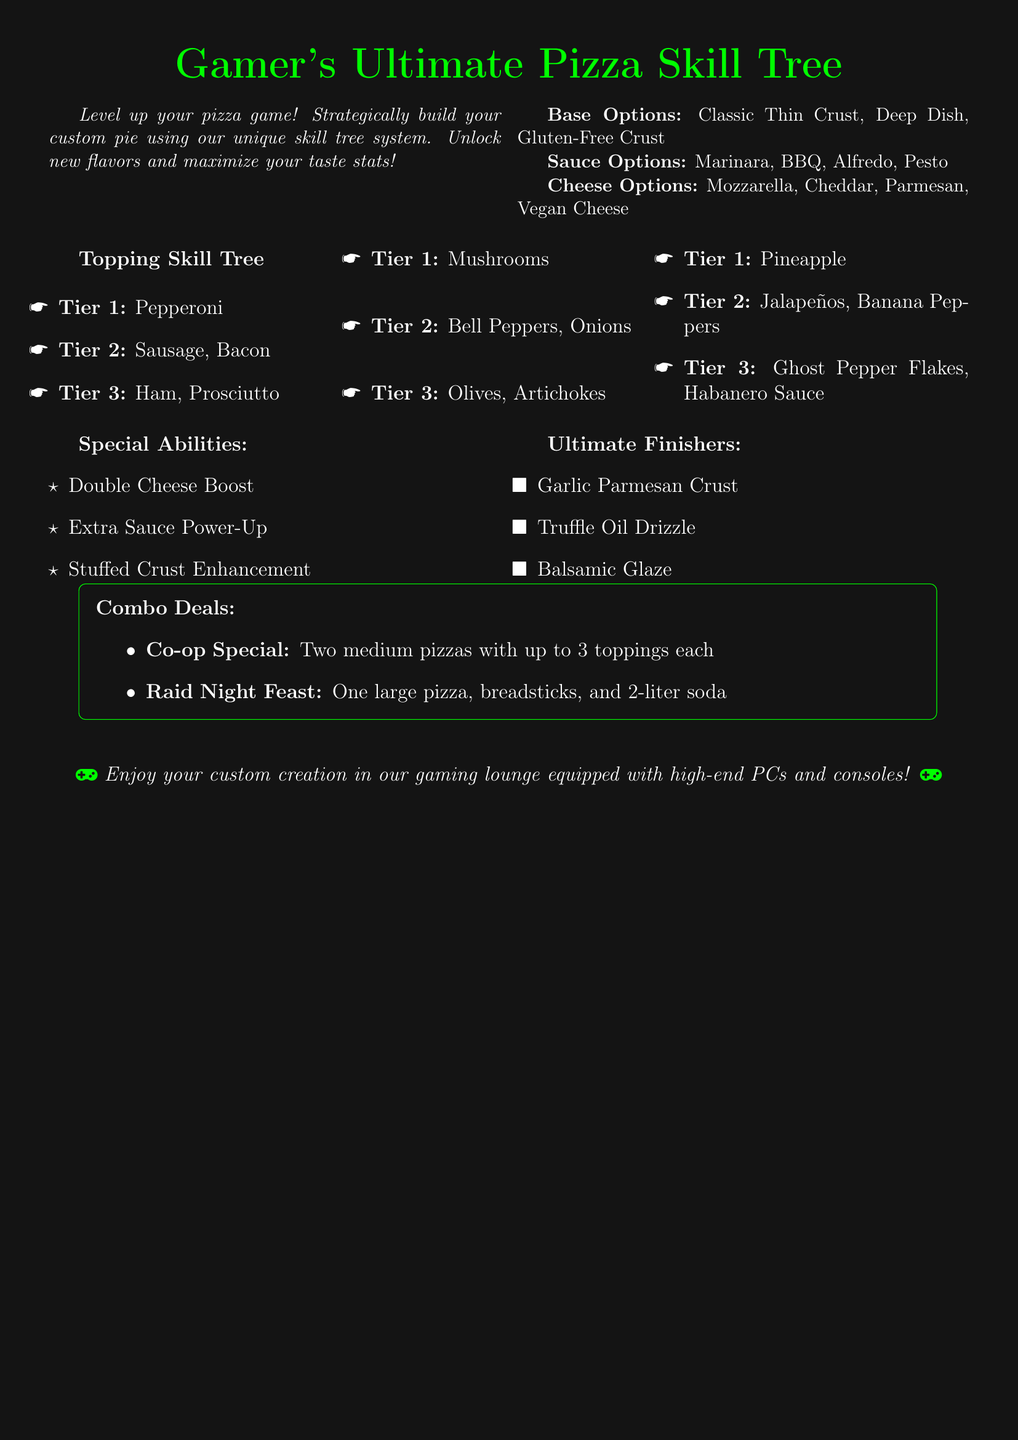What are the base options? The base options are listed directly under the "Base Options" section in the document, which include Classic Thin Crust, Deep Dish, and Gluten-Free Crust.
Answer: Classic Thin Crust, Deep Dish, Gluten-Free Crust What is the highest tier of toppings? The highest tier of toppings is found in the "Topping Skill Tree" section, mentioning the toppings at Tier 3.
Answer: Ghost Pepper Flakes, Habanero Sauce, Olives, Artichokes, Ham, Prosciutto, Jalapeños, Banana Peppers, Sausage, Bacon How many special abilities are listed? The special abilities are outlined in the "Special Abilities" section, and counting them gives the total number.
Answer: 3 What is the co-op special deal? The co-op special is described under "Combo Deals," detailing its contents and format.
Answer: Two medium pizzas with up to 3 toppings each Which pizza base option does not contain gluten? This question refers to the gluten-free option mentioned among the base choices.
Answer: Gluten-Free Crust How many tiers of toppings are available? The tiers of toppings are outlined in the "Topping Skill Tree" with each tier clearly defined.
Answer: 3 What is an ultimate finisher? Ultimate finishers are described in their designated section, detailing a specific type of enhancement for the pizza.
Answer: Garlic Parmesan Crust, Truffle Oil Drizzle, Balsamic Glaze What is the arrangement style of the toppings? The arrangement style refers to how the toppings are organized within the menu, which is based on a skill tree format.
Answer: Skill tree 